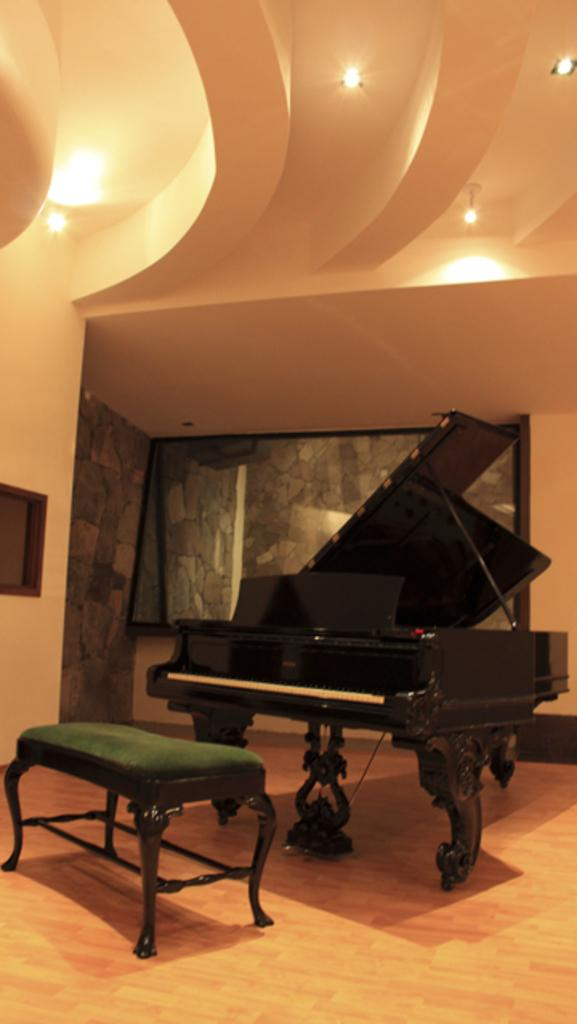What type of structure can be seen in the image? There is a wall in the image. What type of seating is present in the image? There is a bench in the image. What musical instrument is visible in the image? There is a musical keyboard in the image. What type of paper is being used to play the musical keyboard in the image? There is no paper present in the image, and the musical keyboard is not being played. 